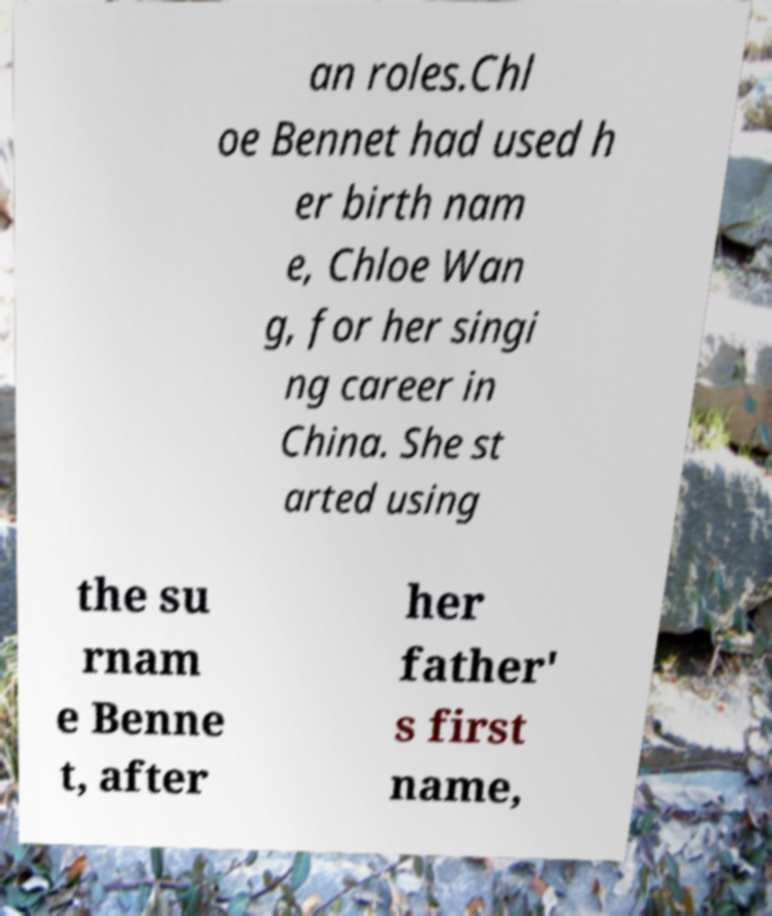I need the written content from this picture converted into text. Can you do that? an roles.Chl oe Bennet had used h er birth nam e, Chloe Wan g, for her singi ng career in China. She st arted using the su rnam e Benne t, after her father' s first name, 